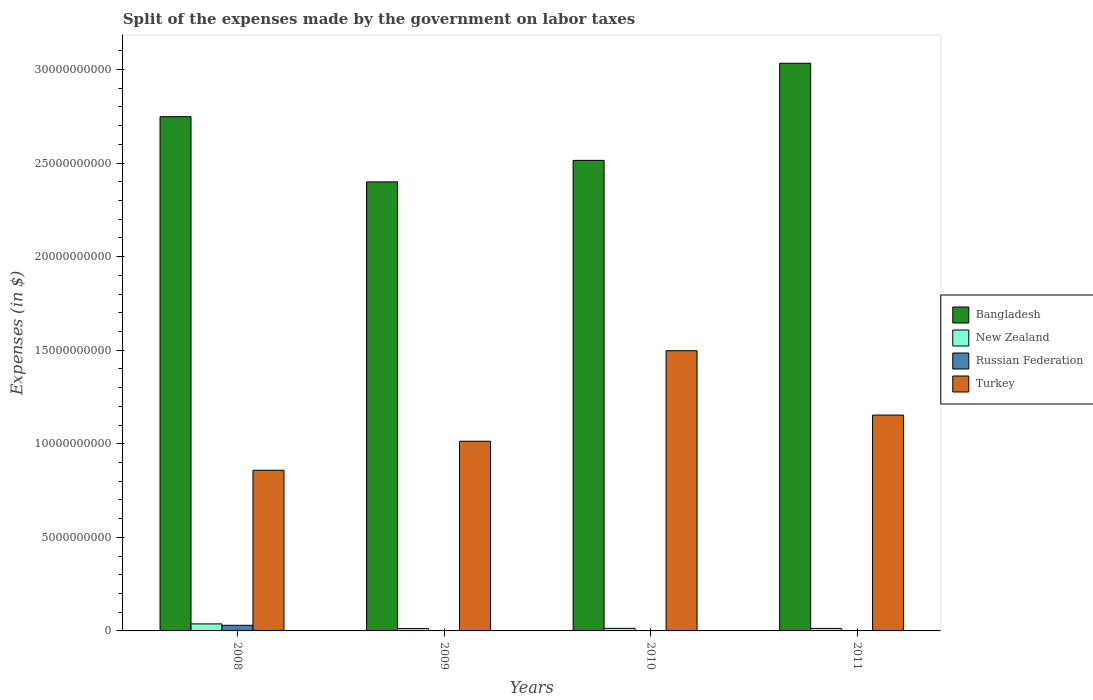How many groups of bars are there?
Give a very brief answer. 4. Are the number of bars on each tick of the X-axis equal?
Give a very brief answer. No. What is the expenses made by the government on labor taxes in Bangladesh in 2010?
Your answer should be compact. 2.51e+1. Across all years, what is the maximum expenses made by the government on labor taxes in New Zealand?
Keep it short and to the point. 3.75e+08. What is the total expenses made by the government on labor taxes in Russian Federation in the graph?
Your answer should be compact. 3.00e+08. What is the difference between the expenses made by the government on labor taxes in Turkey in 2008 and that in 2011?
Your answer should be very brief. -2.95e+09. What is the difference between the expenses made by the government on labor taxes in Russian Federation in 2008 and the expenses made by the government on labor taxes in Bangladesh in 2009?
Keep it short and to the point. -2.37e+1. What is the average expenses made by the government on labor taxes in New Zealand per year?
Your answer should be very brief. 1.93e+08. In the year 2008, what is the difference between the expenses made by the government on labor taxes in Bangladesh and expenses made by the government on labor taxes in Turkey?
Provide a short and direct response. 1.89e+1. What is the ratio of the expenses made by the government on labor taxes in New Zealand in 2008 to that in 2011?
Provide a succinct answer. 2.81. What is the difference between the highest and the second highest expenses made by the government on labor taxes in Bangladesh?
Make the answer very short. 2.85e+09. What is the difference between the highest and the lowest expenses made by the government on labor taxes in Turkey?
Offer a very short reply. 6.39e+09. In how many years, is the expenses made by the government on labor taxes in Bangladesh greater than the average expenses made by the government on labor taxes in Bangladesh taken over all years?
Give a very brief answer. 2. Is it the case that in every year, the sum of the expenses made by the government on labor taxes in Russian Federation and expenses made by the government on labor taxes in Turkey is greater than the sum of expenses made by the government on labor taxes in Bangladesh and expenses made by the government on labor taxes in New Zealand?
Ensure brevity in your answer.  No. Is it the case that in every year, the sum of the expenses made by the government on labor taxes in Russian Federation and expenses made by the government on labor taxes in Turkey is greater than the expenses made by the government on labor taxes in Bangladesh?
Ensure brevity in your answer.  No. How many years are there in the graph?
Make the answer very short. 4. Does the graph contain any zero values?
Give a very brief answer. Yes. Does the graph contain grids?
Provide a short and direct response. No. How many legend labels are there?
Make the answer very short. 4. How are the legend labels stacked?
Keep it short and to the point. Vertical. What is the title of the graph?
Your response must be concise. Split of the expenses made by the government on labor taxes. Does "Europe(developing only)" appear as one of the legend labels in the graph?
Your answer should be very brief. No. What is the label or title of the X-axis?
Offer a very short reply. Years. What is the label or title of the Y-axis?
Make the answer very short. Expenses (in $). What is the Expenses (in $) in Bangladesh in 2008?
Your response must be concise. 2.75e+1. What is the Expenses (in $) of New Zealand in 2008?
Provide a short and direct response. 3.75e+08. What is the Expenses (in $) of Russian Federation in 2008?
Provide a succinct answer. 3.00e+08. What is the Expenses (in $) in Turkey in 2008?
Keep it short and to the point. 8.59e+09. What is the Expenses (in $) of Bangladesh in 2009?
Keep it short and to the point. 2.40e+1. What is the Expenses (in $) of New Zealand in 2009?
Give a very brief answer. 1.28e+08. What is the Expenses (in $) of Turkey in 2009?
Your response must be concise. 1.01e+1. What is the Expenses (in $) of Bangladesh in 2010?
Offer a terse response. 2.51e+1. What is the Expenses (in $) in New Zealand in 2010?
Your response must be concise. 1.37e+08. What is the Expenses (in $) of Russian Federation in 2010?
Offer a very short reply. 0. What is the Expenses (in $) of Turkey in 2010?
Your response must be concise. 1.50e+1. What is the Expenses (in $) of Bangladesh in 2011?
Your answer should be compact. 3.03e+1. What is the Expenses (in $) of New Zealand in 2011?
Offer a very short reply. 1.33e+08. What is the Expenses (in $) of Russian Federation in 2011?
Ensure brevity in your answer.  0. What is the Expenses (in $) of Turkey in 2011?
Make the answer very short. 1.15e+1. Across all years, what is the maximum Expenses (in $) of Bangladesh?
Give a very brief answer. 3.03e+1. Across all years, what is the maximum Expenses (in $) in New Zealand?
Offer a terse response. 3.75e+08. Across all years, what is the maximum Expenses (in $) of Russian Federation?
Give a very brief answer. 3.00e+08. Across all years, what is the maximum Expenses (in $) in Turkey?
Provide a succinct answer. 1.50e+1. Across all years, what is the minimum Expenses (in $) of Bangladesh?
Give a very brief answer. 2.40e+1. Across all years, what is the minimum Expenses (in $) of New Zealand?
Provide a succinct answer. 1.28e+08. Across all years, what is the minimum Expenses (in $) of Russian Federation?
Offer a terse response. 0. Across all years, what is the minimum Expenses (in $) of Turkey?
Ensure brevity in your answer.  8.59e+09. What is the total Expenses (in $) in Bangladesh in the graph?
Ensure brevity in your answer.  1.07e+11. What is the total Expenses (in $) in New Zealand in the graph?
Your answer should be compact. 7.74e+08. What is the total Expenses (in $) of Russian Federation in the graph?
Provide a succinct answer. 3.00e+08. What is the total Expenses (in $) in Turkey in the graph?
Give a very brief answer. 4.52e+1. What is the difference between the Expenses (in $) in Bangladesh in 2008 and that in 2009?
Offer a terse response. 3.48e+09. What is the difference between the Expenses (in $) in New Zealand in 2008 and that in 2009?
Your answer should be compact. 2.47e+08. What is the difference between the Expenses (in $) of Turkey in 2008 and that in 2009?
Offer a terse response. -1.55e+09. What is the difference between the Expenses (in $) in Bangladesh in 2008 and that in 2010?
Your answer should be compact. 2.34e+09. What is the difference between the Expenses (in $) of New Zealand in 2008 and that in 2010?
Your response must be concise. 2.38e+08. What is the difference between the Expenses (in $) in Turkey in 2008 and that in 2010?
Offer a very short reply. -6.39e+09. What is the difference between the Expenses (in $) in Bangladesh in 2008 and that in 2011?
Keep it short and to the point. -2.85e+09. What is the difference between the Expenses (in $) in New Zealand in 2008 and that in 2011?
Ensure brevity in your answer.  2.42e+08. What is the difference between the Expenses (in $) in Turkey in 2008 and that in 2011?
Offer a very short reply. -2.95e+09. What is the difference between the Expenses (in $) in Bangladesh in 2009 and that in 2010?
Give a very brief answer. -1.15e+09. What is the difference between the Expenses (in $) in New Zealand in 2009 and that in 2010?
Your answer should be compact. -9.62e+06. What is the difference between the Expenses (in $) of Turkey in 2009 and that in 2010?
Your response must be concise. -4.84e+09. What is the difference between the Expenses (in $) of Bangladesh in 2009 and that in 2011?
Keep it short and to the point. -6.34e+09. What is the difference between the Expenses (in $) in New Zealand in 2009 and that in 2011?
Make the answer very short. -5.56e+06. What is the difference between the Expenses (in $) of Turkey in 2009 and that in 2011?
Provide a short and direct response. -1.40e+09. What is the difference between the Expenses (in $) of Bangladesh in 2010 and that in 2011?
Keep it short and to the point. -5.19e+09. What is the difference between the Expenses (in $) of New Zealand in 2010 and that in 2011?
Give a very brief answer. 4.06e+06. What is the difference between the Expenses (in $) in Turkey in 2010 and that in 2011?
Provide a short and direct response. 3.44e+09. What is the difference between the Expenses (in $) of Bangladesh in 2008 and the Expenses (in $) of New Zealand in 2009?
Offer a terse response. 2.73e+1. What is the difference between the Expenses (in $) in Bangladesh in 2008 and the Expenses (in $) in Turkey in 2009?
Your response must be concise. 1.73e+1. What is the difference between the Expenses (in $) of New Zealand in 2008 and the Expenses (in $) of Turkey in 2009?
Offer a terse response. -9.76e+09. What is the difference between the Expenses (in $) in Russian Federation in 2008 and the Expenses (in $) in Turkey in 2009?
Provide a short and direct response. -9.84e+09. What is the difference between the Expenses (in $) in Bangladesh in 2008 and the Expenses (in $) in New Zealand in 2010?
Make the answer very short. 2.73e+1. What is the difference between the Expenses (in $) of Bangladesh in 2008 and the Expenses (in $) of Turkey in 2010?
Provide a succinct answer. 1.25e+1. What is the difference between the Expenses (in $) in New Zealand in 2008 and the Expenses (in $) in Turkey in 2010?
Offer a terse response. -1.46e+1. What is the difference between the Expenses (in $) in Russian Federation in 2008 and the Expenses (in $) in Turkey in 2010?
Provide a succinct answer. -1.47e+1. What is the difference between the Expenses (in $) in Bangladesh in 2008 and the Expenses (in $) in New Zealand in 2011?
Provide a succinct answer. 2.73e+1. What is the difference between the Expenses (in $) in Bangladesh in 2008 and the Expenses (in $) in Turkey in 2011?
Your answer should be compact. 1.59e+1. What is the difference between the Expenses (in $) of New Zealand in 2008 and the Expenses (in $) of Turkey in 2011?
Provide a short and direct response. -1.12e+1. What is the difference between the Expenses (in $) in Russian Federation in 2008 and the Expenses (in $) in Turkey in 2011?
Your answer should be very brief. -1.12e+1. What is the difference between the Expenses (in $) of Bangladesh in 2009 and the Expenses (in $) of New Zealand in 2010?
Your answer should be very brief. 2.39e+1. What is the difference between the Expenses (in $) of Bangladesh in 2009 and the Expenses (in $) of Turkey in 2010?
Ensure brevity in your answer.  9.02e+09. What is the difference between the Expenses (in $) in New Zealand in 2009 and the Expenses (in $) in Turkey in 2010?
Provide a succinct answer. -1.48e+1. What is the difference between the Expenses (in $) of Bangladesh in 2009 and the Expenses (in $) of New Zealand in 2011?
Your answer should be compact. 2.39e+1. What is the difference between the Expenses (in $) of Bangladesh in 2009 and the Expenses (in $) of Turkey in 2011?
Offer a very short reply. 1.25e+1. What is the difference between the Expenses (in $) in New Zealand in 2009 and the Expenses (in $) in Turkey in 2011?
Keep it short and to the point. -1.14e+1. What is the difference between the Expenses (in $) in Bangladesh in 2010 and the Expenses (in $) in New Zealand in 2011?
Ensure brevity in your answer.  2.50e+1. What is the difference between the Expenses (in $) in Bangladesh in 2010 and the Expenses (in $) in Turkey in 2011?
Ensure brevity in your answer.  1.36e+1. What is the difference between the Expenses (in $) in New Zealand in 2010 and the Expenses (in $) in Turkey in 2011?
Your answer should be very brief. -1.14e+1. What is the average Expenses (in $) in Bangladesh per year?
Keep it short and to the point. 2.67e+1. What is the average Expenses (in $) in New Zealand per year?
Offer a terse response. 1.93e+08. What is the average Expenses (in $) of Russian Federation per year?
Offer a very short reply. 7.50e+07. What is the average Expenses (in $) in Turkey per year?
Give a very brief answer. 1.13e+1. In the year 2008, what is the difference between the Expenses (in $) of Bangladesh and Expenses (in $) of New Zealand?
Ensure brevity in your answer.  2.71e+1. In the year 2008, what is the difference between the Expenses (in $) of Bangladesh and Expenses (in $) of Russian Federation?
Your response must be concise. 2.72e+1. In the year 2008, what is the difference between the Expenses (in $) of Bangladesh and Expenses (in $) of Turkey?
Provide a succinct answer. 1.89e+1. In the year 2008, what is the difference between the Expenses (in $) of New Zealand and Expenses (in $) of Russian Federation?
Your answer should be very brief. 7.50e+07. In the year 2008, what is the difference between the Expenses (in $) in New Zealand and Expenses (in $) in Turkey?
Keep it short and to the point. -8.21e+09. In the year 2008, what is the difference between the Expenses (in $) in Russian Federation and Expenses (in $) in Turkey?
Offer a terse response. -8.29e+09. In the year 2009, what is the difference between the Expenses (in $) in Bangladesh and Expenses (in $) in New Zealand?
Offer a terse response. 2.39e+1. In the year 2009, what is the difference between the Expenses (in $) in Bangladesh and Expenses (in $) in Turkey?
Your answer should be very brief. 1.39e+1. In the year 2009, what is the difference between the Expenses (in $) in New Zealand and Expenses (in $) in Turkey?
Ensure brevity in your answer.  -1.00e+1. In the year 2010, what is the difference between the Expenses (in $) in Bangladesh and Expenses (in $) in New Zealand?
Give a very brief answer. 2.50e+1. In the year 2010, what is the difference between the Expenses (in $) of Bangladesh and Expenses (in $) of Turkey?
Provide a short and direct response. 1.02e+1. In the year 2010, what is the difference between the Expenses (in $) of New Zealand and Expenses (in $) of Turkey?
Provide a short and direct response. -1.48e+1. In the year 2011, what is the difference between the Expenses (in $) of Bangladesh and Expenses (in $) of New Zealand?
Make the answer very short. 3.02e+1. In the year 2011, what is the difference between the Expenses (in $) in Bangladesh and Expenses (in $) in Turkey?
Give a very brief answer. 1.88e+1. In the year 2011, what is the difference between the Expenses (in $) in New Zealand and Expenses (in $) in Turkey?
Give a very brief answer. -1.14e+1. What is the ratio of the Expenses (in $) in Bangladesh in 2008 to that in 2009?
Ensure brevity in your answer.  1.15. What is the ratio of the Expenses (in $) of New Zealand in 2008 to that in 2009?
Make the answer very short. 2.93. What is the ratio of the Expenses (in $) in Turkey in 2008 to that in 2009?
Your answer should be very brief. 0.85. What is the ratio of the Expenses (in $) in Bangladesh in 2008 to that in 2010?
Keep it short and to the point. 1.09. What is the ratio of the Expenses (in $) of New Zealand in 2008 to that in 2010?
Offer a terse response. 2.73. What is the ratio of the Expenses (in $) of Turkey in 2008 to that in 2010?
Offer a terse response. 0.57. What is the ratio of the Expenses (in $) in Bangladesh in 2008 to that in 2011?
Make the answer very short. 0.91. What is the ratio of the Expenses (in $) in New Zealand in 2008 to that in 2011?
Your response must be concise. 2.81. What is the ratio of the Expenses (in $) in Turkey in 2008 to that in 2011?
Ensure brevity in your answer.  0.74. What is the ratio of the Expenses (in $) of Bangladesh in 2009 to that in 2010?
Make the answer very short. 0.95. What is the ratio of the Expenses (in $) of Turkey in 2009 to that in 2010?
Your response must be concise. 0.68. What is the ratio of the Expenses (in $) of Bangladesh in 2009 to that in 2011?
Offer a terse response. 0.79. What is the ratio of the Expenses (in $) in New Zealand in 2009 to that in 2011?
Your response must be concise. 0.96. What is the ratio of the Expenses (in $) in Turkey in 2009 to that in 2011?
Provide a succinct answer. 0.88. What is the ratio of the Expenses (in $) in Bangladesh in 2010 to that in 2011?
Make the answer very short. 0.83. What is the ratio of the Expenses (in $) of New Zealand in 2010 to that in 2011?
Your answer should be compact. 1.03. What is the ratio of the Expenses (in $) of Turkey in 2010 to that in 2011?
Make the answer very short. 1.3. What is the difference between the highest and the second highest Expenses (in $) in Bangladesh?
Provide a short and direct response. 2.85e+09. What is the difference between the highest and the second highest Expenses (in $) of New Zealand?
Ensure brevity in your answer.  2.38e+08. What is the difference between the highest and the second highest Expenses (in $) in Turkey?
Give a very brief answer. 3.44e+09. What is the difference between the highest and the lowest Expenses (in $) in Bangladesh?
Provide a succinct answer. 6.34e+09. What is the difference between the highest and the lowest Expenses (in $) in New Zealand?
Provide a succinct answer. 2.47e+08. What is the difference between the highest and the lowest Expenses (in $) in Russian Federation?
Offer a terse response. 3.00e+08. What is the difference between the highest and the lowest Expenses (in $) of Turkey?
Ensure brevity in your answer.  6.39e+09. 